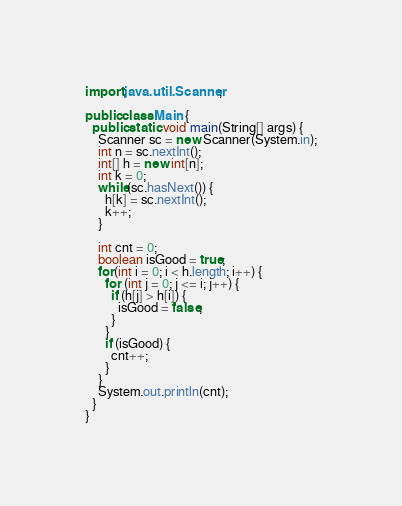Convert code to text. <code><loc_0><loc_0><loc_500><loc_500><_Java_>import java.util.Scanner;

public class Main {
  public static void main(String[] args) {
    Scanner sc = new Scanner(System.in);
    int n = sc.nextInt();
    int[] h = new int[n];
    int k = 0;
    while(sc.hasNext()) {
      h[k] = sc.nextInt();
      k++;
    }
    
    int cnt = 0;
    boolean isGood = true;
    for(int i = 0; i < h.length; i++) {
	  for (int j = 0; j <= i; j++) {
		if (h[j] > h[i]) {
		  isGood = false;
        }
      }
      if (isGood) {
        cnt++;
      }
    }
    System.out.println(cnt);
  }
}</code> 